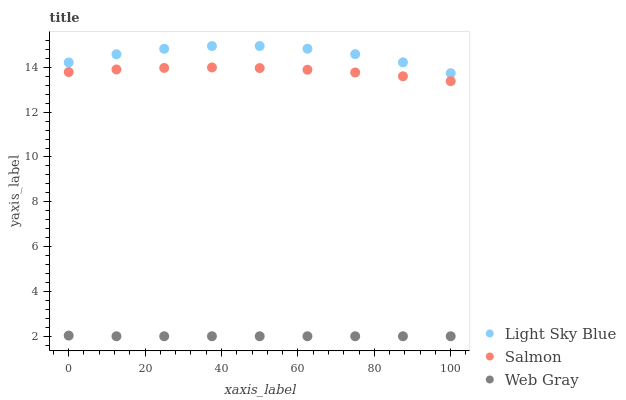Does Web Gray have the minimum area under the curve?
Answer yes or no. Yes. Does Light Sky Blue have the maximum area under the curve?
Answer yes or no. Yes. Does Salmon have the minimum area under the curve?
Answer yes or no. No. Does Salmon have the maximum area under the curve?
Answer yes or no. No. Is Web Gray the smoothest?
Answer yes or no. Yes. Is Light Sky Blue the roughest?
Answer yes or no. Yes. Is Salmon the smoothest?
Answer yes or no. No. Is Salmon the roughest?
Answer yes or no. No. Does Web Gray have the lowest value?
Answer yes or no. Yes. Does Salmon have the lowest value?
Answer yes or no. No. Does Light Sky Blue have the highest value?
Answer yes or no. Yes. Does Salmon have the highest value?
Answer yes or no. No. Is Salmon less than Light Sky Blue?
Answer yes or no. Yes. Is Light Sky Blue greater than Salmon?
Answer yes or no. Yes. Does Salmon intersect Light Sky Blue?
Answer yes or no. No. 